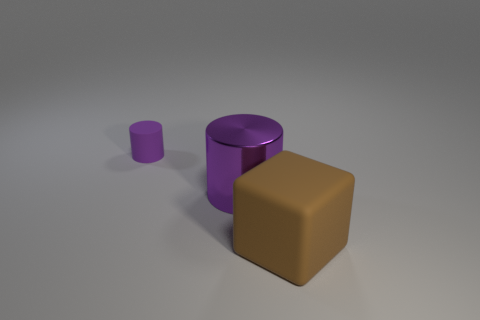Are there more big objects that are right of the tiny cylinder than green shiny cylinders? After closely examining the provided image, it appears that there are no green cylinders present. There is one large brown object to the right of the small purple cylinder, and there are no green shiny cylinders to compare it to. Therefore, the question may be based on an incorrect observation. 